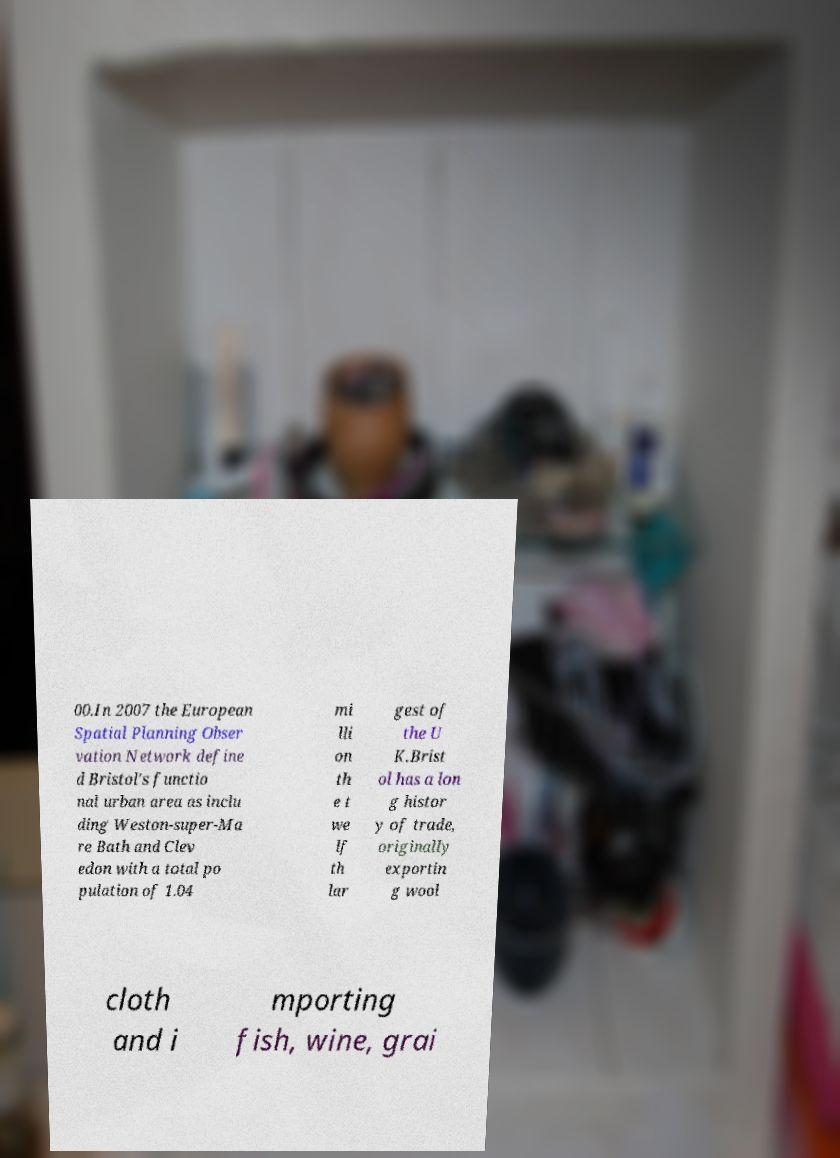Can you read and provide the text displayed in the image?This photo seems to have some interesting text. Can you extract and type it out for me? 00.In 2007 the European Spatial Planning Obser vation Network define d Bristol's functio nal urban area as inclu ding Weston-super-Ma re Bath and Clev edon with a total po pulation of 1.04 mi lli on th e t we lf th lar gest of the U K.Brist ol has a lon g histor y of trade, originally exportin g wool cloth and i mporting fish, wine, grai 